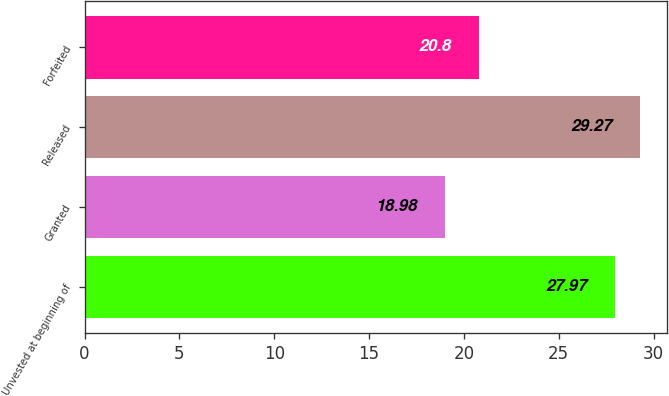<chart> <loc_0><loc_0><loc_500><loc_500><bar_chart><fcel>Unvested at beginning of<fcel>Granted<fcel>Released<fcel>Forfeited<nl><fcel>27.97<fcel>18.98<fcel>29.27<fcel>20.8<nl></chart> 